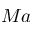<formula> <loc_0><loc_0><loc_500><loc_500>M a</formula> 